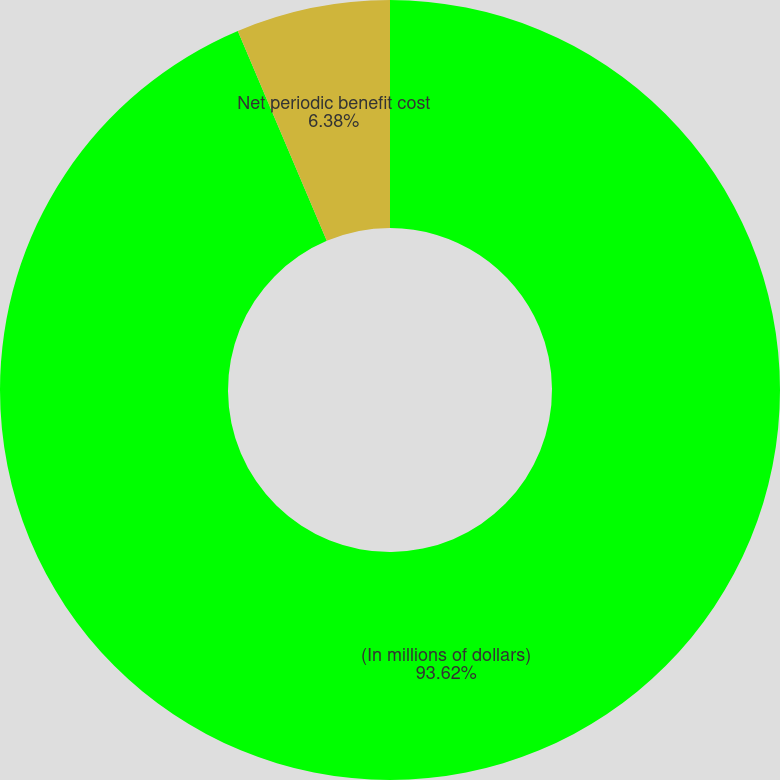<chart> <loc_0><loc_0><loc_500><loc_500><pie_chart><fcel>(In millions of dollars)<fcel>Net periodic benefit cost<nl><fcel>93.62%<fcel>6.38%<nl></chart> 